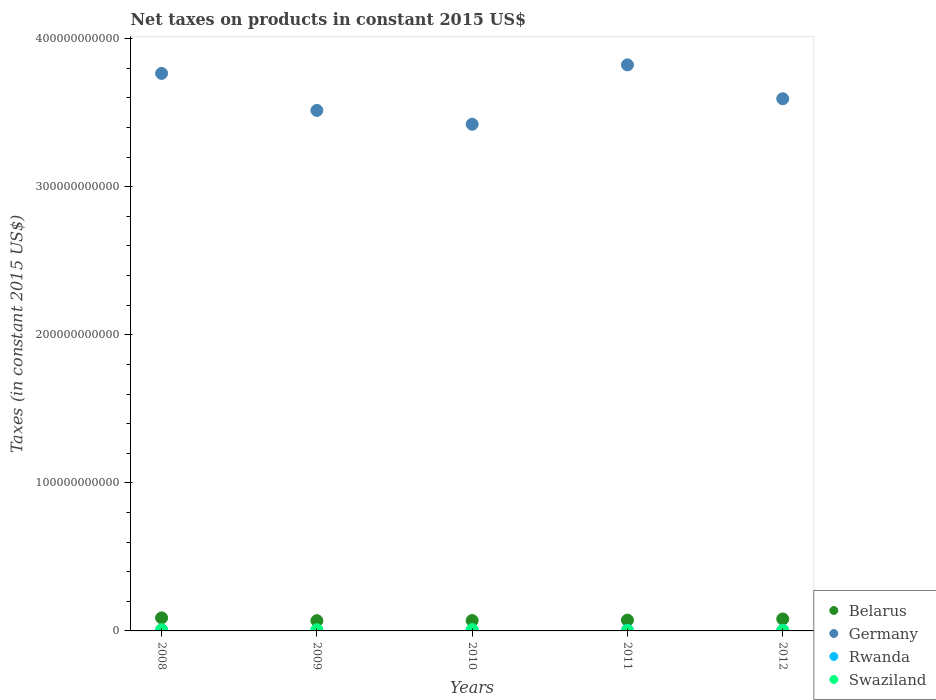How many different coloured dotlines are there?
Keep it short and to the point. 4. What is the net taxes on products in Belarus in 2009?
Offer a very short reply. 6.91e+09. Across all years, what is the maximum net taxes on products in Swaziland?
Give a very brief answer. 8.88e+08. Across all years, what is the minimum net taxes on products in Belarus?
Your response must be concise. 6.91e+09. In which year was the net taxes on products in Belarus minimum?
Make the answer very short. 2009. What is the total net taxes on products in Belarus in the graph?
Provide a short and direct response. 3.81e+1. What is the difference between the net taxes on products in Belarus in 2009 and that in 2012?
Offer a very short reply. -1.16e+09. What is the difference between the net taxes on products in Belarus in 2011 and the net taxes on products in Rwanda in 2010?
Make the answer very short. 6.92e+09. What is the average net taxes on products in Swaziland per year?
Provide a succinct answer. 5.92e+08. In the year 2008, what is the difference between the net taxes on products in Germany and net taxes on products in Rwanda?
Your answer should be compact. 3.76e+11. What is the ratio of the net taxes on products in Belarus in 2008 to that in 2009?
Provide a short and direct response. 1.28. Is the net taxes on products in Rwanda in 2009 less than that in 2012?
Provide a short and direct response. Yes. Is the difference between the net taxes on products in Germany in 2008 and 2009 greater than the difference between the net taxes on products in Rwanda in 2008 and 2009?
Keep it short and to the point. Yes. What is the difference between the highest and the second highest net taxes on products in Swaziland?
Provide a short and direct response. 1.05e+08. What is the difference between the highest and the lowest net taxes on products in Rwanda?
Offer a terse response. 1.21e+08. Is it the case that in every year, the sum of the net taxes on products in Germany and net taxes on products in Swaziland  is greater than the sum of net taxes on products in Belarus and net taxes on products in Rwanda?
Offer a terse response. Yes. Is it the case that in every year, the sum of the net taxes on products in Rwanda and net taxes on products in Germany  is greater than the net taxes on products in Belarus?
Your answer should be compact. Yes. Is the net taxes on products in Belarus strictly greater than the net taxes on products in Swaziland over the years?
Offer a terse response. Yes. Is the net taxes on products in Rwanda strictly less than the net taxes on products in Germany over the years?
Offer a very short reply. Yes. How many years are there in the graph?
Your response must be concise. 5. What is the difference between two consecutive major ticks on the Y-axis?
Keep it short and to the point. 1.00e+11. How many legend labels are there?
Offer a terse response. 4. How are the legend labels stacked?
Keep it short and to the point. Vertical. What is the title of the graph?
Give a very brief answer. Net taxes on products in constant 2015 US$. What is the label or title of the Y-axis?
Your answer should be compact. Taxes (in constant 2015 US$). What is the Taxes (in constant 2015 US$) in Belarus in 2008?
Offer a terse response. 8.82e+09. What is the Taxes (in constant 2015 US$) in Germany in 2008?
Give a very brief answer. 3.77e+11. What is the Taxes (in constant 2015 US$) in Rwanda in 2008?
Your response must be concise. 3.09e+08. What is the Taxes (in constant 2015 US$) of Swaziland in 2008?
Provide a succinct answer. 7.80e+08. What is the Taxes (in constant 2015 US$) in Belarus in 2009?
Your answer should be compact. 6.91e+09. What is the Taxes (in constant 2015 US$) in Germany in 2009?
Make the answer very short. 3.52e+11. What is the Taxes (in constant 2015 US$) of Rwanda in 2009?
Make the answer very short. 3.31e+08. What is the Taxes (in constant 2015 US$) in Swaziland in 2009?
Keep it short and to the point. 7.83e+08. What is the Taxes (in constant 2015 US$) in Belarus in 2010?
Offer a very short reply. 7.01e+09. What is the Taxes (in constant 2015 US$) of Germany in 2010?
Provide a short and direct response. 3.42e+11. What is the Taxes (in constant 2015 US$) of Rwanda in 2010?
Make the answer very short. 3.58e+08. What is the Taxes (in constant 2015 US$) of Swaziland in 2010?
Make the answer very short. 8.88e+08. What is the Taxes (in constant 2015 US$) of Belarus in 2011?
Give a very brief answer. 7.28e+09. What is the Taxes (in constant 2015 US$) of Germany in 2011?
Provide a succinct answer. 3.82e+11. What is the Taxes (in constant 2015 US$) of Rwanda in 2011?
Give a very brief answer. 4.30e+08. What is the Taxes (in constant 2015 US$) of Swaziland in 2011?
Your response must be concise. 2.24e+08. What is the Taxes (in constant 2015 US$) of Belarus in 2012?
Your answer should be very brief. 8.08e+09. What is the Taxes (in constant 2015 US$) of Germany in 2012?
Provide a short and direct response. 3.59e+11. What is the Taxes (in constant 2015 US$) of Rwanda in 2012?
Offer a very short reply. 3.86e+08. What is the Taxes (in constant 2015 US$) in Swaziland in 2012?
Your response must be concise. 2.85e+08. Across all years, what is the maximum Taxes (in constant 2015 US$) of Belarus?
Your answer should be very brief. 8.82e+09. Across all years, what is the maximum Taxes (in constant 2015 US$) in Germany?
Your response must be concise. 3.82e+11. Across all years, what is the maximum Taxes (in constant 2015 US$) of Rwanda?
Offer a terse response. 4.30e+08. Across all years, what is the maximum Taxes (in constant 2015 US$) in Swaziland?
Your answer should be very brief. 8.88e+08. Across all years, what is the minimum Taxes (in constant 2015 US$) in Belarus?
Offer a terse response. 6.91e+09. Across all years, what is the minimum Taxes (in constant 2015 US$) of Germany?
Give a very brief answer. 3.42e+11. Across all years, what is the minimum Taxes (in constant 2015 US$) of Rwanda?
Your response must be concise. 3.09e+08. Across all years, what is the minimum Taxes (in constant 2015 US$) of Swaziland?
Offer a very short reply. 2.24e+08. What is the total Taxes (in constant 2015 US$) in Belarus in the graph?
Keep it short and to the point. 3.81e+1. What is the total Taxes (in constant 2015 US$) in Germany in the graph?
Your response must be concise. 1.81e+12. What is the total Taxes (in constant 2015 US$) of Rwanda in the graph?
Make the answer very short. 1.81e+09. What is the total Taxes (in constant 2015 US$) of Swaziland in the graph?
Keep it short and to the point. 2.96e+09. What is the difference between the Taxes (in constant 2015 US$) in Belarus in 2008 and that in 2009?
Make the answer very short. 1.91e+09. What is the difference between the Taxes (in constant 2015 US$) of Germany in 2008 and that in 2009?
Give a very brief answer. 2.50e+1. What is the difference between the Taxes (in constant 2015 US$) of Rwanda in 2008 and that in 2009?
Offer a terse response. -2.18e+07. What is the difference between the Taxes (in constant 2015 US$) of Swaziland in 2008 and that in 2009?
Your response must be concise. -3.25e+06. What is the difference between the Taxes (in constant 2015 US$) of Belarus in 2008 and that in 2010?
Offer a very short reply. 1.81e+09. What is the difference between the Taxes (in constant 2015 US$) in Germany in 2008 and that in 2010?
Ensure brevity in your answer.  3.44e+1. What is the difference between the Taxes (in constant 2015 US$) of Rwanda in 2008 and that in 2010?
Keep it short and to the point. -4.94e+07. What is the difference between the Taxes (in constant 2015 US$) of Swaziland in 2008 and that in 2010?
Provide a succinct answer. -1.08e+08. What is the difference between the Taxes (in constant 2015 US$) in Belarus in 2008 and that in 2011?
Offer a very short reply. 1.54e+09. What is the difference between the Taxes (in constant 2015 US$) in Germany in 2008 and that in 2011?
Keep it short and to the point. -5.77e+09. What is the difference between the Taxes (in constant 2015 US$) in Rwanda in 2008 and that in 2011?
Your response must be concise. -1.21e+08. What is the difference between the Taxes (in constant 2015 US$) in Swaziland in 2008 and that in 2011?
Ensure brevity in your answer.  5.56e+08. What is the difference between the Taxes (in constant 2015 US$) in Belarus in 2008 and that in 2012?
Provide a short and direct response. 7.45e+08. What is the difference between the Taxes (in constant 2015 US$) of Germany in 2008 and that in 2012?
Provide a short and direct response. 1.71e+1. What is the difference between the Taxes (in constant 2015 US$) of Rwanda in 2008 and that in 2012?
Offer a terse response. -7.68e+07. What is the difference between the Taxes (in constant 2015 US$) in Swaziland in 2008 and that in 2012?
Provide a succinct answer. 4.95e+08. What is the difference between the Taxes (in constant 2015 US$) of Belarus in 2009 and that in 2010?
Your answer should be very brief. -9.48e+07. What is the difference between the Taxes (in constant 2015 US$) in Germany in 2009 and that in 2010?
Provide a succinct answer. 9.34e+09. What is the difference between the Taxes (in constant 2015 US$) of Rwanda in 2009 and that in 2010?
Offer a very short reply. -2.76e+07. What is the difference between the Taxes (in constant 2015 US$) of Swaziland in 2009 and that in 2010?
Make the answer very short. -1.05e+08. What is the difference between the Taxes (in constant 2015 US$) of Belarus in 2009 and that in 2011?
Offer a very short reply. -3.64e+08. What is the difference between the Taxes (in constant 2015 US$) of Germany in 2009 and that in 2011?
Your answer should be very brief. -3.08e+1. What is the difference between the Taxes (in constant 2015 US$) of Rwanda in 2009 and that in 2011?
Ensure brevity in your answer.  -9.90e+07. What is the difference between the Taxes (in constant 2015 US$) of Swaziland in 2009 and that in 2011?
Make the answer very short. 5.59e+08. What is the difference between the Taxes (in constant 2015 US$) of Belarus in 2009 and that in 2012?
Give a very brief answer. -1.16e+09. What is the difference between the Taxes (in constant 2015 US$) of Germany in 2009 and that in 2012?
Provide a short and direct response. -7.88e+09. What is the difference between the Taxes (in constant 2015 US$) of Rwanda in 2009 and that in 2012?
Your answer should be compact. -5.50e+07. What is the difference between the Taxes (in constant 2015 US$) of Swaziland in 2009 and that in 2012?
Give a very brief answer. 4.98e+08. What is the difference between the Taxes (in constant 2015 US$) in Belarus in 2010 and that in 2011?
Provide a short and direct response. -2.70e+08. What is the difference between the Taxes (in constant 2015 US$) in Germany in 2010 and that in 2011?
Give a very brief answer. -4.01e+1. What is the difference between the Taxes (in constant 2015 US$) in Rwanda in 2010 and that in 2011?
Provide a short and direct response. -7.14e+07. What is the difference between the Taxes (in constant 2015 US$) of Swaziland in 2010 and that in 2011?
Your response must be concise. 6.64e+08. What is the difference between the Taxes (in constant 2015 US$) of Belarus in 2010 and that in 2012?
Your response must be concise. -1.07e+09. What is the difference between the Taxes (in constant 2015 US$) of Germany in 2010 and that in 2012?
Your answer should be very brief. -1.72e+1. What is the difference between the Taxes (in constant 2015 US$) of Rwanda in 2010 and that in 2012?
Give a very brief answer. -2.74e+07. What is the difference between the Taxes (in constant 2015 US$) of Swaziland in 2010 and that in 2012?
Make the answer very short. 6.03e+08. What is the difference between the Taxes (in constant 2015 US$) in Belarus in 2011 and that in 2012?
Your answer should be very brief. -7.99e+08. What is the difference between the Taxes (in constant 2015 US$) in Germany in 2011 and that in 2012?
Make the answer very short. 2.29e+1. What is the difference between the Taxes (in constant 2015 US$) in Rwanda in 2011 and that in 2012?
Give a very brief answer. 4.40e+07. What is the difference between the Taxes (in constant 2015 US$) in Swaziland in 2011 and that in 2012?
Provide a short and direct response. -6.11e+07. What is the difference between the Taxes (in constant 2015 US$) of Belarus in 2008 and the Taxes (in constant 2015 US$) of Germany in 2009?
Your answer should be compact. -3.43e+11. What is the difference between the Taxes (in constant 2015 US$) in Belarus in 2008 and the Taxes (in constant 2015 US$) in Rwanda in 2009?
Your answer should be very brief. 8.49e+09. What is the difference between the Taxes (in constant 2015 US$) in Belarus in 2008 and the Taxes (in constant 2015 US$) in Swaziland in 2009?
Provide a succinct answer. 8.04e+09. What is the difference between the Taxes (in constant 2015 US$) in Germany in 2008 and the Taxes (in constant 2015 US$) in Rwanda in 2009?
Offer a very short reply. 3.76e+11. What is the difference between the Taxes (in constant 2015 US$) in Germany in 2008 and the Taxes (in constant 2015 US$) in Swaziland in 2009?
Provide a succinct answer. 3.76e+11. What is the difference between the Taxes (in constant 2015 US$) of Rwanda in 2008 and the Taxes (in constant 2015 US$) of Swaziland in 2009?
Offer a terse response. -4.74e+08. What is the difference between the Taxes (in constant 2015 US$) in Belarus in 2008 and the Taxes (in constant 2015 US$) in Germany in 2010?
Provide a short and direct response. -3.33e+11. What is the difference between the Taxes (in constant 2015 US$) of Belarus in 2008 and the Taxes (in constant 2015 US$) of Rwanda in 2010?
Provide a short and direct response. 8.46e+09. What is the difference between the Taxes (in constant 2015 US$) in Belarus in 2008 and the Taxes (in constant 2015 US$) in Swaziland in 2010?
Give a very brief answer. 7.93e+09. What is the difference between the Taxes (in constant 2015 US$) in Germany in 2008 and the Taxes (in constant 2015 US$) in Rwanda in 2010?
Offer a terse response. 3.76e+11. What is the difference between the Taxes (in constant 2015 US$) of Germany in 2008 and the Taxes (in constant 2015 US$) of Swaziland in 2010?
Give a very brief answer. 3.76e+11. What is the difference between the Taxes (in constant 2015 US$) of Rwanda in 2008 and the Taxes (in constant 2015 US$) of Swaziland in 2010?
Give a very brief answer. -5.79e+08. What is the difference between the Taxes (in constant 2015 US$) of Belarus in 2008 and the Taxes (in constant 2015 US$) of Germany in 2011?
Give a very brief answer. -3.74e+11. What is the difference between the Taxes (in constant 2015 US$) in Belarus in 2008 and the Taxes (in constant 2015 US$) in Rwanda in 2011?
Offer a very short reply. 8.39e+09. What is the difference between the Taxes (in constant 2015 US$) of Belarus in 2008 and the Taxes (in constant 2015 US$) of Swaziland in 2011?
Give a very brief answer. 8.60e+09. What is the difference between the Taxes (in constant 2015 US$) in Germany in 2008 and the Taxes (in constant 2015 US$) in Rwanda in 2011?
Give a very brief answer. 3.76e+11. What is the difference between the Taxes (in constant 2015 US$) of Germany in 2008 and the Taxes (in constant 2015 US$) of Swaziland in 2011?
Your answer should be compact. 3.76e+11. What is the difference between the Taxes (in constant 2015 US$) in Rwanda in 2008 and the Taxes (in constant 2015 US$) in Swaziland in 2011?
Your answer should be compact. 8.52e+07. What is the difference between the Taxes (in constant 2015 US$) in Belarus in 2008 and the Taxes (in constant 2015 US$) in Germany in 2012?
Provide a short and direct response. -3.51e+11. What is the difference between the Taxes (in constant 2015 US$) in Belarus in 2008 and the Taxes (in constant 2015 US$) in Rwanda in 2012?
Ensure brevity in your answer.  8.43e+09. What is the difference between the Taxes (in constant 2015 US$) of Belarus in 2008 and the Taxes (in constant 2015 US$) of Swaziland in 2012?
Your answer should be very brief. 8.54e+09. What is the difference between the Taxes (in constant 2015 US$) of Germany in 2008 and the Taxes (in constant 2015 US$) of Rwanda in 2012?
Keep it short and to the point. 3.76e+11. What is the difference between the Taxes (in constant 2015 US$) in Germany in 2008 and the Taxes (in constant 2015 US$) in Swaziland in 2012?
Give a very brief answer. 3.76e+11. What is the difference between the Taxes (in constant 2015 US$) of Rwanda in 2008 and the Taxes (in constant 2015 US$) of Swaziland in 2012?
Offer a very short reply. 2.41e+07. What is the difference between the Taxes (in constant 2015 US$) in Belarus in 2009 and the Taxes (in constant 2015 US$) in Germany in 2010?
Provide a succinct answer. -3.35e+11. What is the difference between the Taxes (in constant 2015 US$) of Belarus in 2009 and the Taxes (in constant 2015 US$) of Rwanda in 2010?
Your answer should be compact. 6.55e+09. What is the difference between the Taxes (in constant 2015 US$) of Belarus in 2009 and the Taxes (in constant 2015 US$) of Swaziland in 2010?
Provide a succinct answer. 6.02e+09. What is the difference between the Taxes (in constant 2015 US$) in Germany in 2009 and the Taxes (in constant 2015 US$) in Rwanda in 2010?
Offer a very short reply. 3.51e+11. What is the difference between the Taxes (in constant 2015 US$) of Germany in 2009 and the Taxes (in constant 2015 US$) of Swaziland in 2010?
Provide a succinct answer. 3.51e+11. What is the difference between the Taxes (in constant 2015 US$) in Rwanda in 2009 and the Taxes (in constant 2015 US$) in Swaziland in 2010?
Offer a very short reply. -5.57e+08. What is the difference between the Taxes (in constant 2015 US$) of Belarus in 2009 and the Taxes (in constant 2015 US$) of Germany in 2011?
Your answer should be compact. -3.75e+11. What is the difference between the Taxes (in constant 2015 US$) of Belarus in 2009 and the Taxes (in constant 2015 US$) of Rwanda in 2011?
Ensure brevity in your answer.  6.48e+09. What is the difference between the Taxes (in constant 2015 US$) in Belarus in 2009 and the Taxes (in constant 2015 US$) in Swaziland in 2011?
Offer a terse response. 6.69e+09. What is the difference between the Taxes (in constant 2015 US$) in Germany in 2009 and the Taxes (in constant 2015 US$) in Rwanda in 2011?
Offer a very short reply. 3.51e+11. What is the difference between the Taxes (in constant 2015 US$) in Germany in 2009 and the Taxes (in constant 2015 US$) in Swaziland in 2011?
Your answer should be compact. 3.51e+11. What is the difference between the Taxes (in constant 2015 US$) of Rwanda in 2009 and the Taxes (in constant 2015 US$) of Swaziland in 2011?
Your answer should be very brief. 1.07e+08. What is the difference between the Taxes (in constant 2015 US$) of Belarus in 2009 and the Taxes (in constant 2015 US$) of Germany in 2012?
Keep it short and to the point. -3.53e+11. What is the difference between the Taxes (in constant 2015 US$) of Belarus in 2009 and the Taxes (in constant 2015 US$) of Rwanda in 2012?
Offer a terse response. 6.53e+09. What is the difference between the Taxes (in constant 2015 US$) in Belarus in 2009 and the Taxes (in constant 2015 US$) in Swaziland in 2012?
Offer a terse response. 6.63e+09. What is the difference between the Taxes (in constant 2015 US$) of Germany in 2009 and the Taxes (in constant 2015 US$) of Rwanda in 2012?
Your response must be concise. 3.51e+11. What is the difference between the Taxes (in constant 2015 US$) in Germany in 2009 and the Taxes (in constant 2015 US$) in Swaziland in 2012?
Your answer should be compact. 3.51e+11. What is the difference between the Taxes (in constant 2015 US$) in Rwanda in 2009 and the Taxes (in constant 2015 US$) in Swaziland in 2012?
Offer a terse response. 4.59e+07. What is the difference between the Taxes (in constant 2015 US$) in Belarus in 2010 and the Taxes (in constant 2015 US$) in Germany in 2011?
Offer a terse response. -3.75e+11. What is the difference between the Taxes (in constant 2015 US$) in Belarus in 2010 and the Taxes (in constant 2015 US$) in Rwanda in 2011?
Give a very brief answer. 6.58e+09. What is the difference between the Taxes (in constant 2015 US$) in Belarus in 2010 and the Taxes (in constant 2015 US$) in Swaziland in 2011?
Provide a short and direct response. 6.78e+09. What is the difference between the Taxes (in constant 2015 US$) of Germany in 2010 and the Taxes (in constant 2015 US$) of Rwanda in 2011?
Your answer should be very brief. 3.42e+11. What is the difference between the Taxes (in constant 2015 US$) in Germany in 2010 and the Taxes (in constant 2015 US$) in Swaziland in 2011?
Your answer should be compact. 3.42e+11. What is the difference between the Taxes (in constant 2015 US$) of Rwanda in 2010 and the Taxes (in constant 2015 US$) of Swaziland in 2011?
Provide a short and direct response. 1.35e+08. What is the difference between the Taxes (in constant 2015 US$) of Belarus in 2010 and the Taxes (in constant 2015 US$) of Germany in 2012?
Your answer should be compact. -3.52e+11. What is the difference between the Taxes (in constant 2015 US$) of Belarus in 2010 and the Taxes (in constant 2015 US$) of Rwanda in 2012?
Offer a terse response. 6.62e+09. What is the difference between the Taxes (in constant 2015 US$) of Belarus in 2010 and the Taxes (in constant 2015 US$) of Swaziland in 2012?
Your answer should be very brief. 6.72e+09. What is the difference between the Taxes (in constant 2015 US$) in Germany in 2010 and the Taxes (in constant 2015 US$) in Rwanda in 2012?
Ensure brevity in your answer.  3.42e+11. What is the difference between the Taxes (in constant 2015 US$) in Germany in 2010 and the Taxes (in constant 2015 US$) in Swaziland in 2012?
Give a very brief answer. 3.42e+11. What is the difference between the Taxes (in constant 2015 US$) of Rwanda in 2010 and the Taxes (in constant 2015 US$) of Swaziland in 2012?
Provide a short and direct response. 7.34e+07. What is the difference between the Taxes (in constant 2015 US$) in Belarus in 2011 and the Taxes (in constant 2015 US$) in Germany in 2012?
Your answer should be very brief. -3.52e+11. What is the difference between the Taxes (in constant 2015 US$) of Belarus in 2011 and the Taxes (in constant 2015 US$) of Rwanda in 2012?
Your answer should be compact. 6.89e+09. What is the difference between the Taxes (in constant 2015 US$) in Belarus in 2011 and the Taxes (in constant 2015 US$) in Swaziland in 2012?
Your answer should be very brief. 6.99e+09. What is the difference between the Taxes (in constant 2015 US$) of Germany in 2011 and the Taxes (in constant 2015 US$) of Rwanda in 2012?
Ensure brevity in your answer.  3.82e+11. What is the difference between the Taxes (in constant 2015 US$) in Germany in 2011 and the Taxes (in constant 2015 US$) in Swaziland in 2012?
Give a very brief answer. 3.82e+11. What is the difference between the Taxes (in constant 2015 US$) of Rwanda in 2011 and the Taxes (in constant 2015 US$) of Swaziland in 2012?
Your response must be concise. 1.45e+08. What is the average Taxes (in constant 2015 US$) of Belarus per year?
Offer a terse response. 7.62e+09. What is the average Taxes (in constant 2015 US$) in Germany per year?
Provide a short and direct response. 3.62e+11. What is the average Taxes (in constant 2015 US$) of Rwanda per year?
Provide a succinct answer. 3.63e+08. What is the average Taxes (in constant 2015 US$) of Swaziland per year?
Give a very brief answer. 5.92e+08. In the year 2008, what is the difference between the Taxes (in constant 2015 US$) in Belarus and Taxes (in constant 2015 US$) in Germany?
Provide a succinct answer. -3.68e+11. In the year 2008, what is the difference between the Taxes (in constant 2015 US$) of Belarus and Taxes (in constant 2015 US$) of Rwanda?
Keep it short and to the point. 8.51e+09. In the year 2008, what is the difference between the Taxes (in constant 2015 US$) in Belarus and Taxes (in constant 2015 US$) in Swaziland?
Give a very brief answer. 8.04e+09. In the year 2008, what is the difference between the Taxes (in constant 2015 US$) of Germany and Taxes (in constant 2015 US$) of Rwanda?
Provide a short and direct response. 3.76e+11. In the year 2008, what is the difference between the Taxes (in constant 2015 US$) in Germany and Taxes (in constant 2015 US$) in Swaziland?
Offer a terse response. 3.76e+11. In the year 2008, what is the difference between the Taxes (in constant 2015 US$) in Rwanda and Taxes (in constant 2015 US$) in Swaziland?
Provide a short and direct response. -4.71e+08. In the year 2009, what is the difference between the Taxes (in constant 2015 US$) of Belarus and Taxes (in constant 2015 US$) of Germany?
Your answer should be compact. -3.45e+11. In the year 2009, what is the difference between the Taxes (in constant 2015 US$) in Belarus and Taxes (in constant 2015 US$) in Rwanda?
Your answer should be compact. 6.58e+09. In the year 2009, what is the difference between the Taxes (in constant 2015 US$) in Belarus and Taxes (in constant 2015 US$) in Swaziland?
Keep it short and to the point. 6.13e+09. In the year 2009, what is the difference between the Taxes (in constant 2015 US$) in Germany and Taxes (in constant 2015 US$) in Rwanda?
Your answer should be compact. 3.51e+11. In the year 2009, what is the difference between the Taxes (in constant 2015 US$) in Germany and Taxes (in constant 2015 US$) in Swaziland?
Provide a short and direct response. 3.51e+11. In the year 2009, what is the difference between the Taxes (in constant 2015 US$) of Rwanda and Taxes (in constant 2015 US$) of Swaziland?
Ensure brevity in your answer.  -4.52e+08. In the year 2010, what is the difference between the Taxes (in constant 2015 US$) of Belarus and Taxes (in constant 2015 US$) of Germany?
Your answer should be compact. -3.35e+11. In the year 2010, what is the difference between the Taxes (in constant 2015 US$) of Belarus and Taxes (in constant 2015 US$) of Rwanda?
Keep it short and to the point. 6.65e+09. In the year 2010, what is the difference between the Taxes (in constant 2015 US$) in Belarus and Taxes (in constant 2015 US$) in Swaziland?
Keep it short and to the point. 6.12e+09. In the year 2010, what is the difference between the Taxes (in constant 2015 US$) in Germany and Taxes (in constant 2015 US$) in Rwanda?
Your response must be concise. 3.42e+11. In the year 2010, what is the difference between the Taxes (in constant 2015 US$) of Germany and Taxes (in constant 2015 US$) of Swaziland?
Provide a succinct answer. 3.41e+11. In the year 2010, what is the difference between the Taxes (in constant 2015 US$) in Rwanda and Taxes (in constant 2015 US$) in Swaziland?
Your answer should be very brief. -5.30e+08. In the year 2011, what is the difference between the Taxes (in constant 2015 US$) in Belarus and Taxes (in constant 2015 US$) in Germany?
Offer a very short reply. -3.75e+11. In the year 2011, what is the difference between the Taxes (in constant 2015 US$) in Belarus and Taxes (in constant 2015 US$) in Rwanda?
Make the answer very short. 6.85e+09. In the year 2011, what is the difference between the Taxes (in constant 2015 US$) of Belarus and Taxes (in constant 2015 US$) of Swaziland?
Your answer should be compact. 7.05e+09. In the year 2011, what is the difference between the Taxes (in constant 2015 US$) in Germany and Taxes (in constant 2015 US$) in Rwanda?
Give a very brief answer. 3.82e+11. In the year 2011, what is the difference between the Taxes (in constant 2015 US$) of Germany and Taxes (in constant 2015 US$) of Swaziland?
Offer a terse response. 3.82e+11. In the year 2011, what is the difference between the Taxes (in constant 2015 US$) of Rwanda and Taxes (in constant 2015 US$) of Swaziland?
Offer a terse response. 2.06e+08. In the year 2012, what is the difference between the Taxes (in constant 2015 US$) of Belarus and Taxes (in constant 2015 US$) of Germany?
Give a very brief answer. -3.51e+11. In the year 2012, what is the difference between the Taxes (in constant 2015 US$) of Belarus and Taxes (in constant 2015 US$) of Rwanda?
Provide a short and direct response. 7.69e+09. In the year 2012, what is the difference between the Taxes (in constant 2015 US$) of Belarus and Taxes (in constant 2015 US$) of Swaziland?
Your answer should be compact. 7.79e+09. In the year 2012, what is the difference between the Taxes (in constant 2015 US$) in Germany and Taxes (in constant 2015 US$) in Rwanda?
Provide a short and direct response. 3.59e+11. In the year 2012, what is the difference between the Taxes (in constant 2015 US$) in Germany and Taxes (in constant 2015 US$) in Swaziland?
Your response must be concise. 3.59e+11. In the year 2012, what is the difference between the Taxes (in constant 2015 US$) in Rwanda and Taxes (in constant 2015 US$) in Swaziland?
Your answer should be very brief. 1.01e+08. What is the ratio of the Taxes (in constant 2015 US$) in Belarus in 2008 to that in 2009?
Your answer should be very brief. 1.28. What is the ratio of the Taxes (in constant 2015 US$) of Germany in 2008 to that in 2009?
Make the answer very short. 1.07. What is the ratio of the Taxes (in constant 2015 US$) of Rwanda in 2008 to that in 2009?
Offer a terse response. 0.93. What is the ratio of the Taxes (in constant 2015 US$) of Swaziland in 2008 to that in 2009?
Your answer should be very brief. 1. What is the ratio of the Taxes (in constant 2015 US$) of Belarus in 2008 to that in 2010?
Offer a terse response. 1.26. What is the ratio of the Taxes (in constant 2015 US$) of Germany in 2008 to that in 2010?
Keep it short and to the point. 1.1. What is the ratio of the Taxes (in constant 2015 US$) of Rwanda in 2008 to that in 2010?
Ensure brevity in your answer.  0.86. What is the ratio of the Taxes (in constant 2015 US$) of Swaziland in 2008 to that in 2010?
Offer a terse response. 0.88. What is the ratio of the Taxes (in constant 2015 US$) of Belarus in 2008 to that in 2011?
Offer a very short reply. 1.21. What is the ratio of the Taxes (in constant 2015 US$) of Germany in 2008 to that in 2011?
Your answer should be compact. 0.98. What is the ratio of the Taxes (in constant 2015 US$) of Rwanda in 2008 to that in 2011?
Ensure brevity in your answer.  0.72. What is the ratio of the Taxes (in constant 2015 US$) in Swaziland in 2008 to that in 2011?
Provide a short and direct response. 3.48. What is the ratio of the Taxes (in constant 2015 US$) in Belarus in 2008 to that in 2012?
Give a very brief answer. 1.09. What is the ratio of the Taxes (in constant 2015 US$) of Germany in 2008 to that in 2012?
Provide a short and direct response. 1.05. What is the ratio of the Taxes (in constant 2015 US$) of Rwanda in 2008 to that in 2012?
Give a very brief answer. 0.8. What is the ratio of the Taxes (in constant 2015 US$) in Swaziland in 2008 to that in 2012?
Your response must be concise. 2.74. What is the ratio of the Taxes (in constant 2015 US$) in Belarus in 2009 to that in 2010?
Make the answer very short. 0.99. What is the ratio of the Taxes (in constant 2015 US$) of Germany in 2009 to that in 2010?
Provide a short and direct response. 1.03. What is the ratio of the Taxes (in constant 2015 US$) of Rwanda in 2009 to that in 2010?
Offer a terse response. 0.92. What is the ratio of the Taxes (in constant 2015 US$) of Swaziland in 2009 to that in 2010?
Keep it short and to the point. 0.88. What is the ratio of the Taxes (in constant 2015 US$) in Belarus in 2009 to that in 2011?
Ensure brevity in your answer.  0.95. What is the ratio of the Taxes (in constant 2015 US$) of Germany in 2009 to that in 2011?
Your answer should be very brief. 0.92. What is the ratio of the Taxes (in constant 2015 US$) of Rwanda in 2009 to that in 2011?
Your answer should be very brief. 0.77. What is the ratio of the Taxes (in constant 2015 US$) in Swaziland in 2009 to that in 2011?
Offer a terse response. 3.5. What is the ratio of the Taxes (in constant 2015 US$) of Belarus in 2009 to that in 2012?
Your response must be concise. 0.86. What is the ratio of the Taxes (in constant 2015 US$) in Germany in 2009 to that in 2012?
Your answer should be very brief. 0.98. What is the ratio of the Taxes (in constant 2015 US$) of Rwanda in 2009 to that in 2012?
Offer a terse response. 0.86. What is the ratio of the Taxes (in constant 2015 US$) of Swaziland in 2009 to that in 2012?
Make the answer very short. 2.75. What is the ratio of the Taxes (in constant 2015 US$) of Belarus in 2010 to that in 2011?
Give a very brief answer. 0.96. What is the ratio of the Taxes (in constant 2015 US$) of Germany in 2010 to that in 2011?
Give a very brief answer. 0.9. What is the ratio of the Taxes (in constant 2015 US$) in Rwanda in 2010 to that in 2011?
Your response must be concise. 0.83. What is the ratio of the Taxes (in constant 2015 US$) of Swaziland in 2010 to that in 2011?
Provide a succinct answer. 3.97. What is the ratio of the Taxes (in constant 2015 US$) in Belarus in 2010 to that in 2012?
Give a very brief answer. 0.87. What is the ratio of the Taxes (in constant 2015 US$) of Germany in 2010 to that in 2012?
Your response must be concise. 0.95. What is the ratio of the Taxes (in constant 2015 US$) of Rwanda in 2010 to that in 2012?
Your response must be concise. 0.93. What is the ratio of the Taxes (in constant 2015 US$) in Swaziland in 2010 to that in 2012?
Keep it short and to the point. 3.12. What is the ratio of the Taxes (in constant 2015 US$) in Belarus in 2011 to that in 2012?
Your response must be concise. 0.9. What is the ratio of the Taxes (in constant 2015 US$) of Germany in 2011 to that in 2012?
Make the answer very short. 1.06. What is the ratio of the Taxes (in constant 2015 US$) of Rwanda in 2011 to that in 2012?
Your answer should be compact. 1.11. What is the ratio of the Taxes (in constant 2015 US$) of Swaziland in 2011 to that in 2012?
Provide a succinct answer. 0.79. What is the difference between the highest and the second highest Taxes (in constant 2015 US$) in Belarus?
Provide a succinct answer. 7.45e+08. What is the difference between the highest and the second highest Taxes (in constant 2015 US$) in Germany?
Keep it short and to the point. 5.77e+09. What is the difference between the highest and the second highest Taxes (in constant 2015 US$) in Rwanda?
Your response must be concise. 4.40e+07. What is the difference between the highest and the second highest Taxes (in constant 2015 US$) of Swaziland?
Keep it short and to the point. 1.05e+08. What is the difference between the highest and the lowest Taxes (in constant 2015 US$) of Belarus?
Offer a terse response. 1.91e+09. What is the difference between the highest and the lowest Taxes (in constant 2015 US$) in Germany?
Offer a terse response. 4.01e+1. What is the difference between the highest and the lowest Taxes (in constant 2015 US$) in Rwanda?
Your response must be concise. 1.21e+08. What is the difference between the highest and the lowest Taxes (in constant 2015 US$) in Swaziland?
Keep it short and to the point. 6.64e+08. 